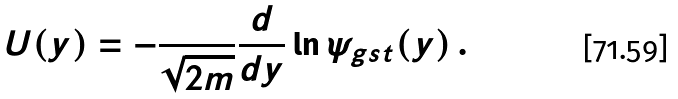Convert formula to latex. <formula><loc_0><loc_0><loc_500><loc_500>U ( y ) = - \frac { } { \sqrt { 2 m } } \frac { d } { d y } \ln \psi _ { g s t } ( y ) \, .</formula> 